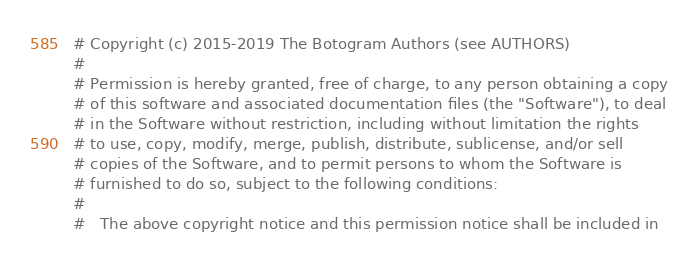<code> <loc_0><loc_0><loc_500><loc_500><_Python_># Copyright (c) 2015-2019 The Botogram Authors (see AUTHORS)
#
# Permission is hereby granted, free of charge, to any person obtaining a copy
# of this software and associated documentation files (the "Software"), to deal
# in the Software without restriction, including without limitation the rights
# to use, copy, modify, merge, publish, distribute, sublicense, and/or sell
# copies of the Software, and to permit persons to whom the Software is
# furnished to do so, subject to the following conditions:
#
#   The above copyright notice and this permission notice shall be included in</code> 